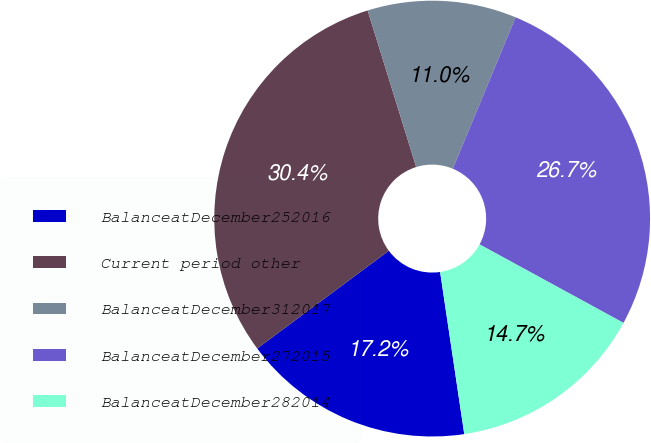<chart> <loc_0><loc_0><loc_500><loc_500><pie_chart><fcel>BalanceatDecember252016<fcel>Current period other<fcel>BalanceatDecember312017<fcel>BalanceatDecember272015<fcel>BalanceatDecember282014<nl><fcel>17.19%<fcel>30.38%<fcel>11.04%<fcel>26.69%<fcel>14.7%<nl></chart> 